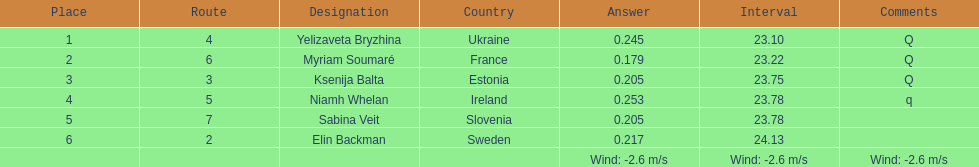Identify the sportswoman who finished first in heat 1 of the women's 200 meters. Yelizaveta Bryzhina. 